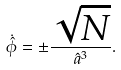Convert formula to latex. <formula><loc_0><loc_0><loc_500><loc_500>\dot { \hat { \phi } } = \pm \frac { \sqrt { N } } { \hat { a } ^ { 3 } } .</formula> 